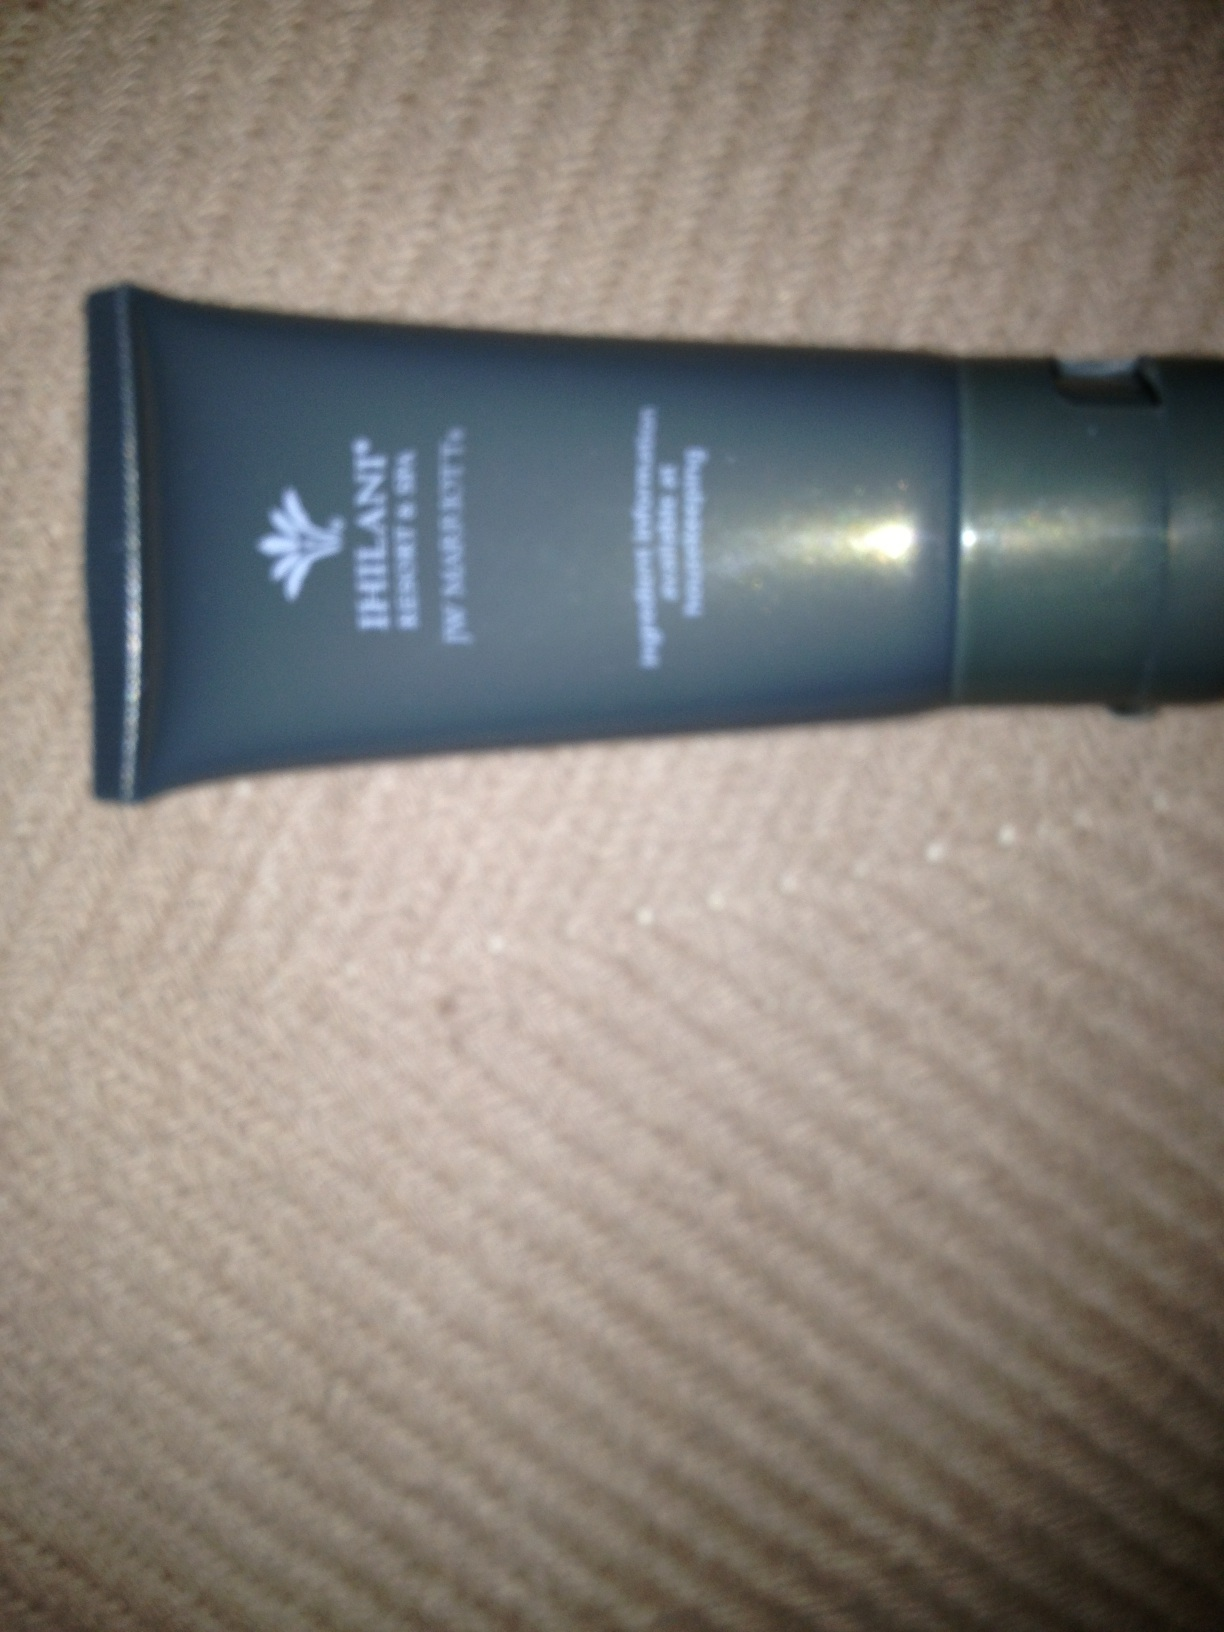Can you suggest some ways that I could use a skincare product like this? Certainly! Skincare products like creams or lotions can be used after cleansing your skin to moisturize and protect the skin barrier. If it’s a treatment product, such as a serum or spot treatment, it should be applied according to the specific product instructions, typically after cleansing and before moisturizing. Always test a new skincare product on a small skin area first to check for any allergic reactions. 